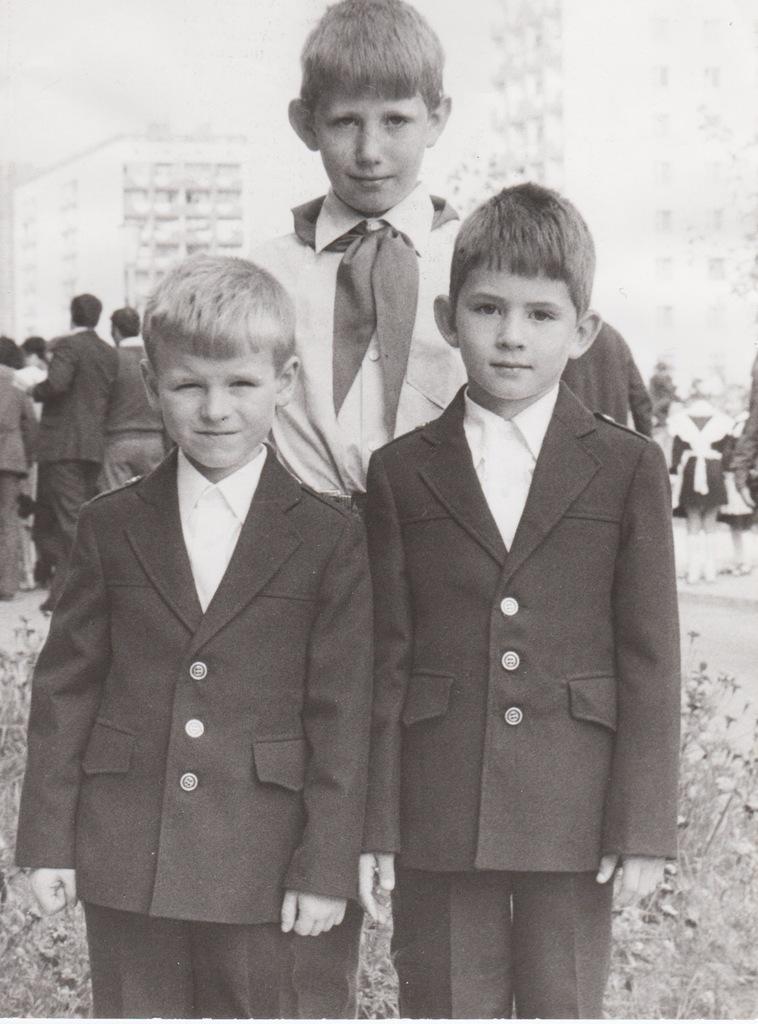Please provide a concise description of this image. In this picture we can see three boys standing on the ground and in the background we can see buildings,people. 